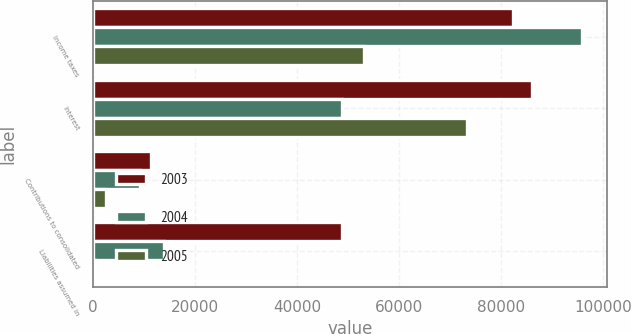Convert chart to OTSL. <chart><loc_0><loc_0><loc_500><loc_500><stacked_bar_chart><ecel><fcel>Income taxes<fcel>Interest<fcel>Contributions to consolidated<fcel>Liabilities assumed in<nl><fcel>2003<fcel>82275<fcel>86035<fcel>11326<fcel>48822<nl><fcel>2004<fcel>95943<fcel>48822<fcel>9167<fcel>13991<nl><fcel>2005<fcel>53074<fcel>73278<fcel>2645<fcel>357<nl></chart> 